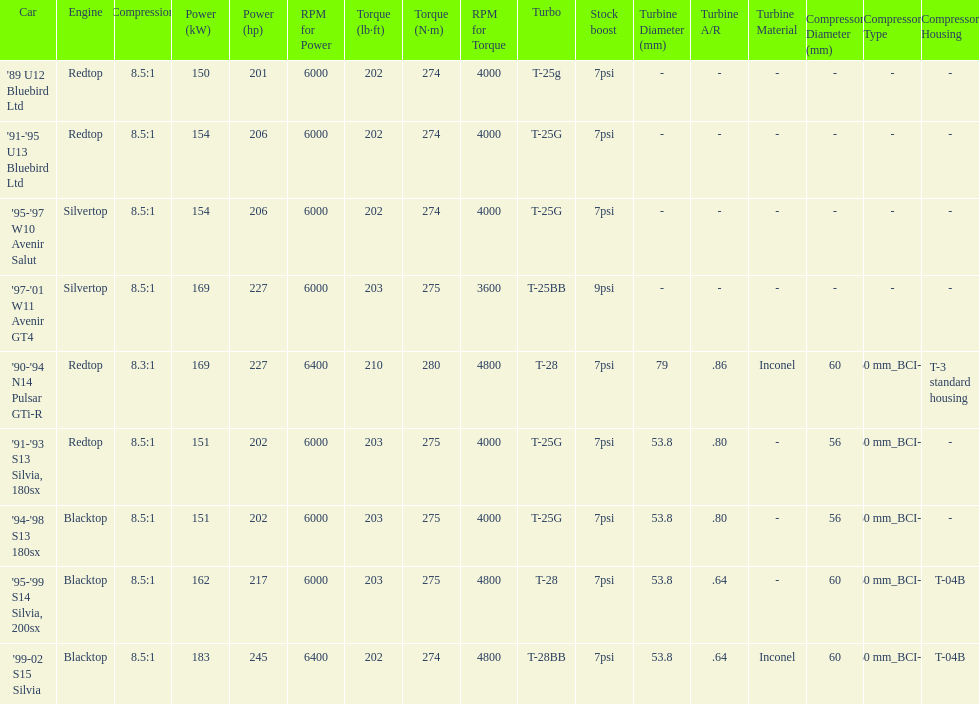Which car is the only one with more than 230 hp? '99-02 S15 Silvia. 